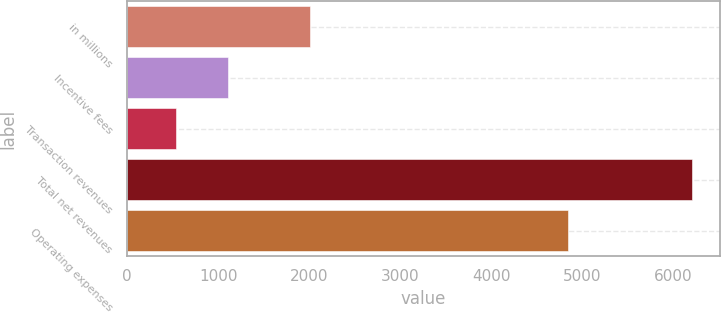Convert chart to OTSL. <chart><loc_0><loc_0><loc_500><loc_500><bar_chart><fcel>in millions<fcel>Incentive fees<fcel>Transaction revenues<fcel>Total net revenues<fcel>Operating expenses<nl><fcel>2015<fcel>1105.7<fcel>539<fcel>6206<fcel>4841<nl></chart> 